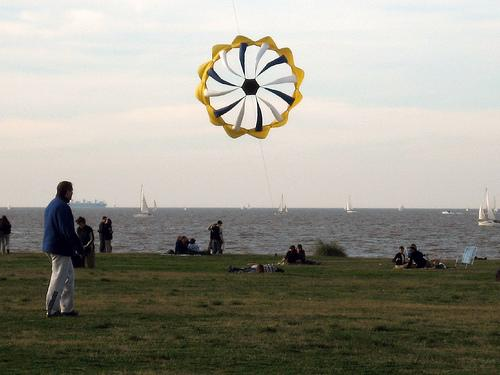The item in the sky looks most like what?

Choices:
A) dog
B) house
C) wheel
D) cat wheel 